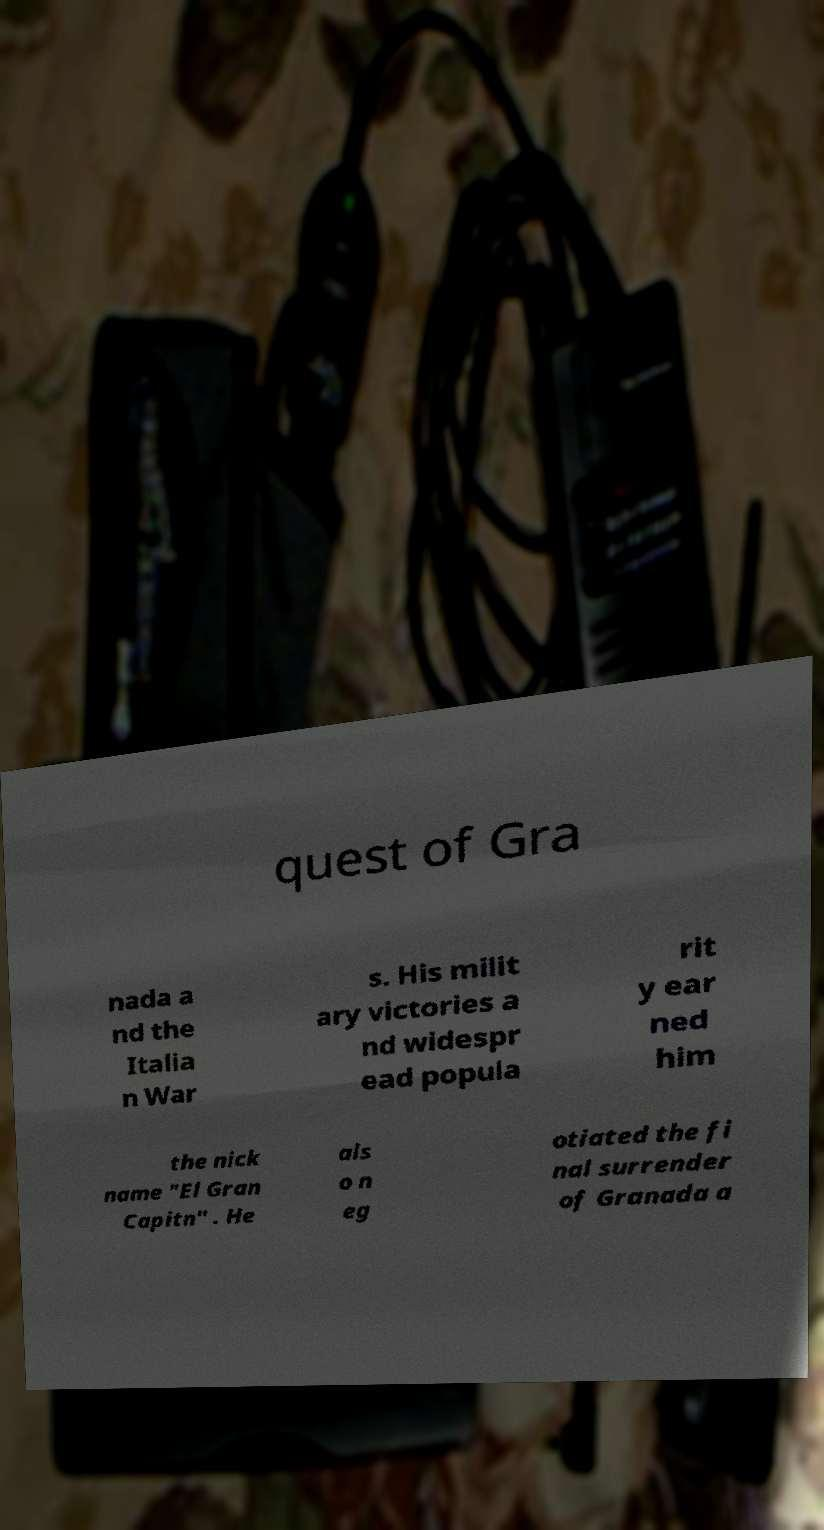For documentation purposes, I need the text within this image transcribed. Could you provide that? quest of Gra nada a nd the Italia n War s. His milit ary victories a nd widespr ead popula rit y ear ned him the nick name "El Gran Capitn" . He als o n eg otiated the fi nal surrender of Granada a 